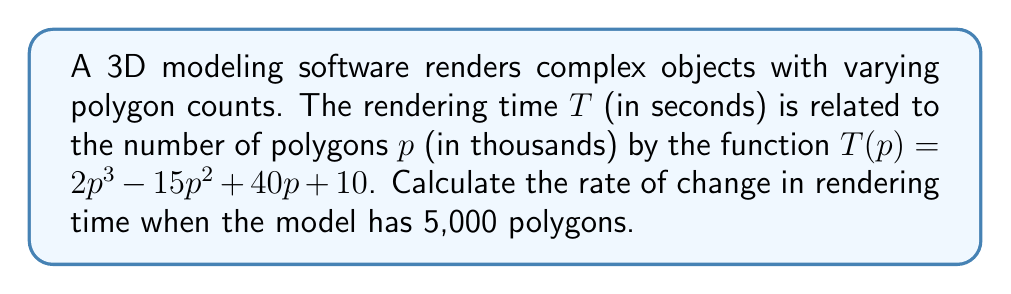Could you help me with this problem? To find the rate of change in rendering time with respect to the number of polygons, we need to compute the derivative of the function $T(p)$.

Step 1: Identify the function
$$T(p) = 2p^3 - 15p^2 + 40p + 10$$

Step 2: Calculate the derivative
Using the power rule and constant rule:
$$T'(p) = 6p^2 - 30p + 40$$

Step 3: Evaluate the derivative at p = 5
Since the question asks for 5,000 polygons, and p is in thousands, we use p = 5:
$$T'(5) = 6(5^2) - 30(5) + 40$$
$$T'(5) = 6(25) - 150 + 40$$
$$T'(5) = 150 - 150 + 40$$
$$T'(5) = 40$$

Step 4: Interpret the result
The rate of change in rendering time when the model has 5,000 polygons is 40 seconds per thousand polygons, or 0.04 seconds per polygon.
Answer: 40 seconds per thousand polygons 